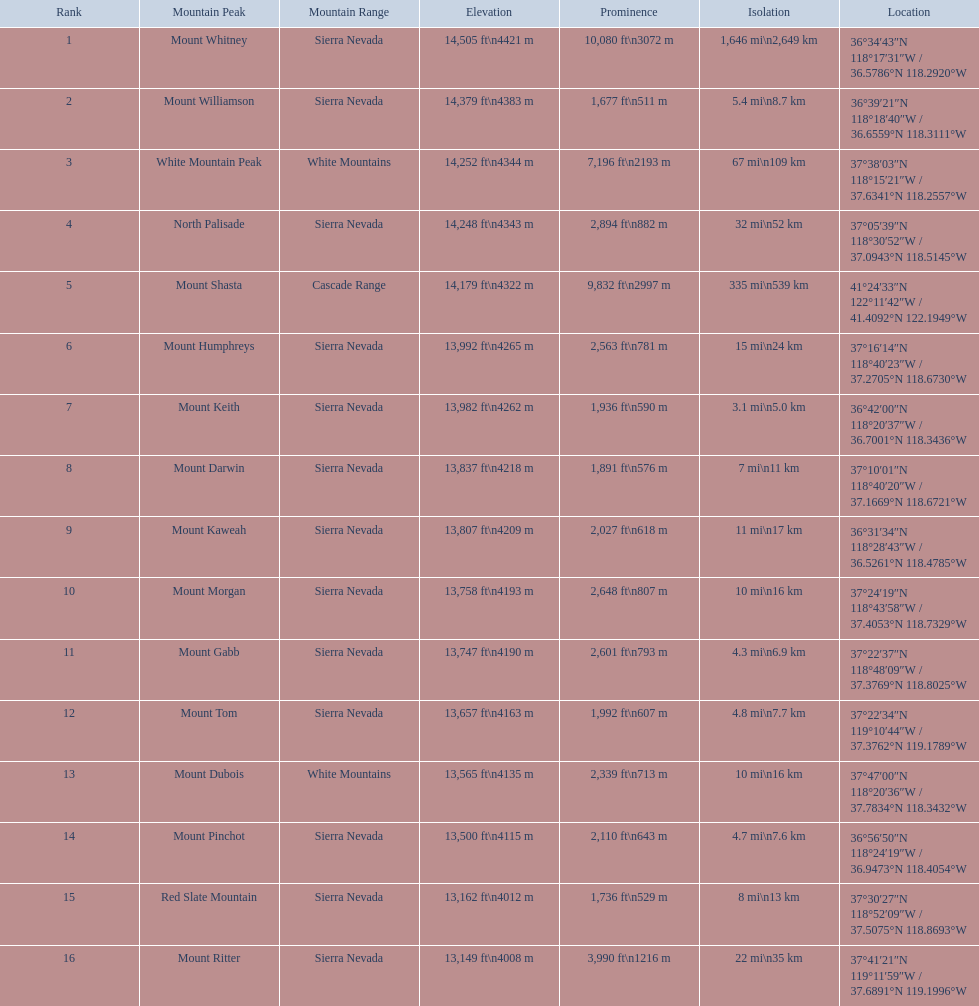What are all the mountain summits? Mount Whitney, Mount Williamson, White Mountain Peak, North Palisade, Mount Shasta, Mount Humphreys, Mount Keith, Mount Darwin, Mount Kaweah, Mount Morgan, Mount Gabb, Mount Tom, Mount Dubois, Mount Pinchot, Red Slate Mountain, Mount Ritter. In which ranges can they be found? Sierra Nevada, Sierra Nevada, White Mountains, Sierra Nevada, Cascade Range, Sierra Nevada, Sierra Nevada, Sierra Nevada, Sierra Nevada, Sierra Nevada, Sierra Nevada, Sierra Nevada, White Mountains, Sierra Nevada, Sierra Nevada, Sierra Nevada. And which mountain summit is situated in the cascade range? Mount Shasta. What are the different peak heights? 14,505 ft\n4421 m, 14,379 ft\n4383 m, 14,252 ft\n4344 m, 14,248 ft\n4343 m, 14,179 ft\n4322 m, 13,992 ft\n4265 m, 13,982 ft\n4262 m, 13,837 ft\n4218 m, 13,807 ft\n4209 m, 13,758 ft\n4193 m, 13,747 ft\n4190 m, 13,657 ft\n4163 m, 13,565 ft\n4135 m, 13,500 ft\n4115 m, 13,162 ft\n4012 m, 13,149 ft\n4008 m. Which one is the tallest? 14,505 ft\n4421 m. Which peak has an elevation of 14,505 feet? Mount Whitney. 